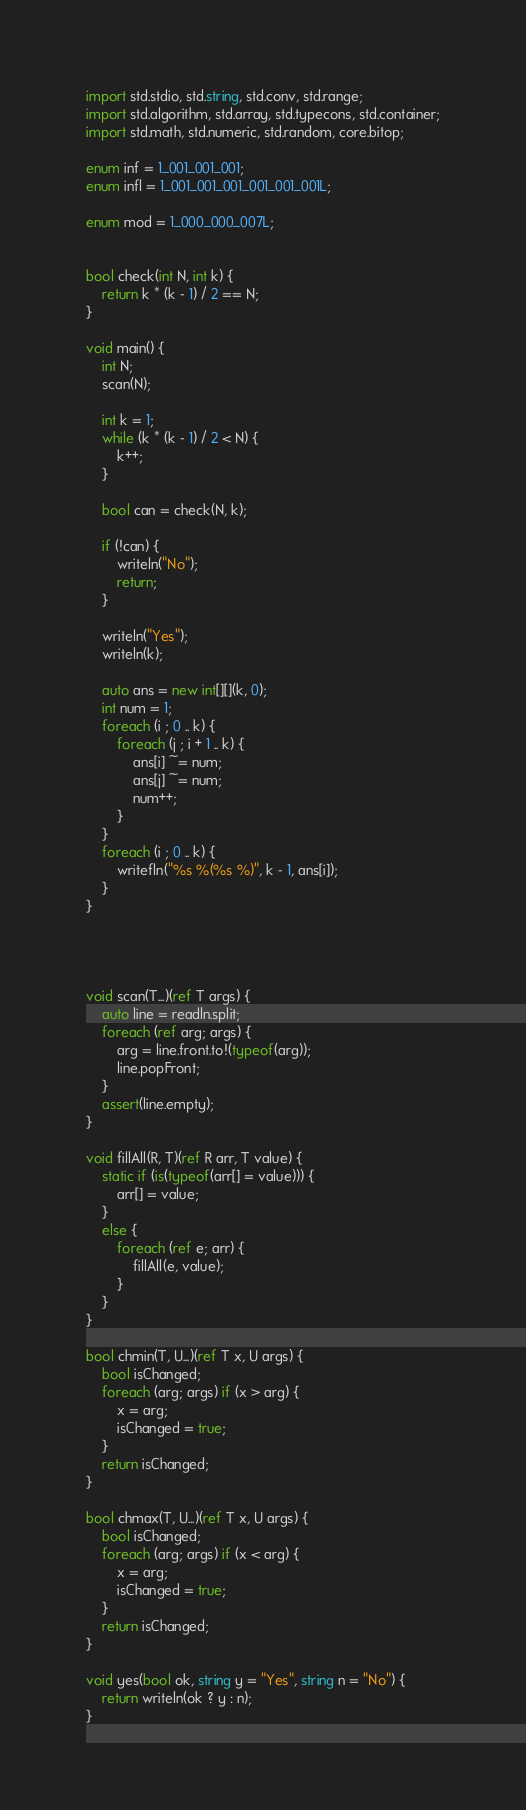Convert code to text. <code><loc_0><loc_0><loc_500><loc_500><_D_>import std.stdio, std.string, std.conv, std.range;
import std.algorithm, std.array, std.typecons, std.container;
import std.math, std.numeric, std.random, core.bitop;

enum inf = 1_001_001_001;
enum infl = 1_001_001_001_001_001_001L;

enum mod = 1_000_000_007L;


bool check(int N, int k) {
    return k * (k - 1) / 2 == N;
}

void main() {
    int N;
    scan(N);

    int k = 1;
    while (k * (k - 1) / 2 < N) {
        k++;
    }

    bool can = check(N, k);

    if (!can) {
        writeln("No");
        return;
    }

    writeln("Yes");
    writeln(k);

    auto ans = new int[][](k, 0);
    int num = 1;
    foreach (i ; 0 .. k) {
        foreach (j ; i + 1 .. k) {
            ans[i] ~= num;
            ans[j] ~= num;
            num++;
        }
    }
    foreach (i ; 0 .. k) {
        writefln("%s %(%s %)", k - 1, ans[i]);
    }
}




void scan(T...)(ref T args) {
    auto line = readln.split;
    foreach (ref arg; args) {
        arg = line.front.to!(typeof(arg));
        line.popFront;
    }
    assert(line.empty);
}

void fillAll(R, T)(ref R arr, T value) {
    static if (is(typeof(arr[] = value))) {
        arr[] = value;
    }
    else {
        foreach (ref e; arr) {
            fillAll(e, value);
        }
    }
}

bool chmin(T, U...)(ref T x, U args) {
    bool isChanged;
    foreach (arg; args) if (x > arg) {
        x = arg;
        isChanged = true;
    }
    return isChanged;
}

bool chmax(T, U...)(ref T x, U args) {
    bool isChanged;
    foreach (arg; args) if (x < arg) {
        x = arg;
        isChanged = true;
    }
    return isChanged;
}

void yes(bool ok, string y = "Yes", string n = "No") {
    return writeln(ok ? y : n);
}
</code> 